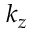<formula> <loc_0><loc_0><loc_500><loc_500>k _ { z }</formula> 